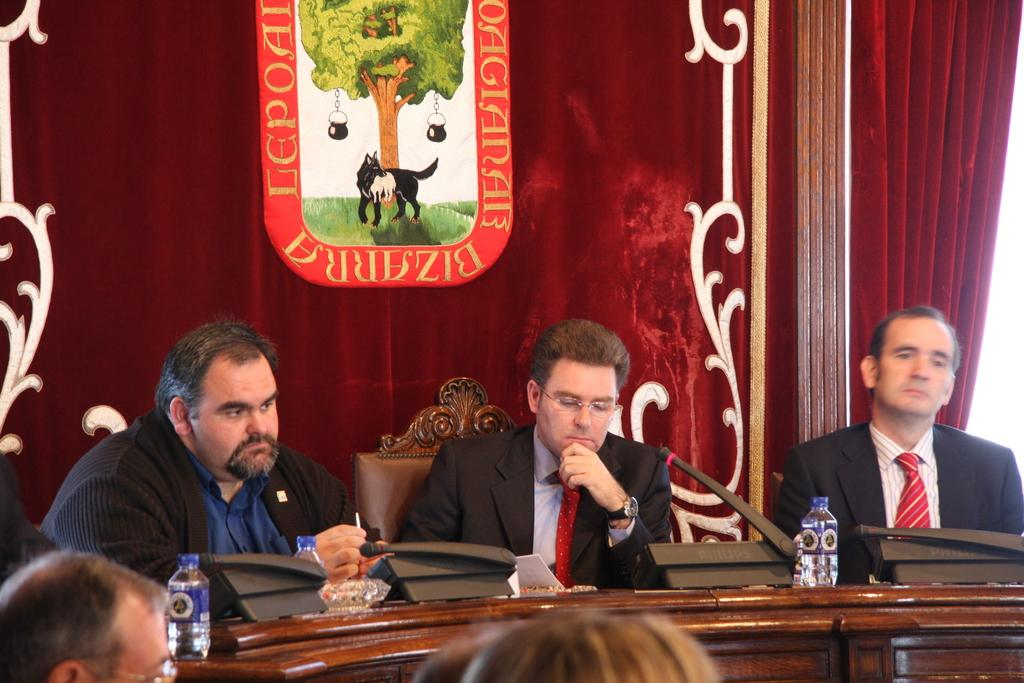How many people are in the image? There are three persons in the image. What are the persons doing in the image? The persons are sitting on chairs. What objects are in front of the persons? There is a microphone and a water bottle in front of the persons. What can be seen at the back side of the image? There is a curtain at the back side of the image. What type of pies are being served to the persons in the image? There are no pies present in the image. How much rice is visible on the plates of the persons in the image? There is no rice visible on the plates of the persons in the image. 